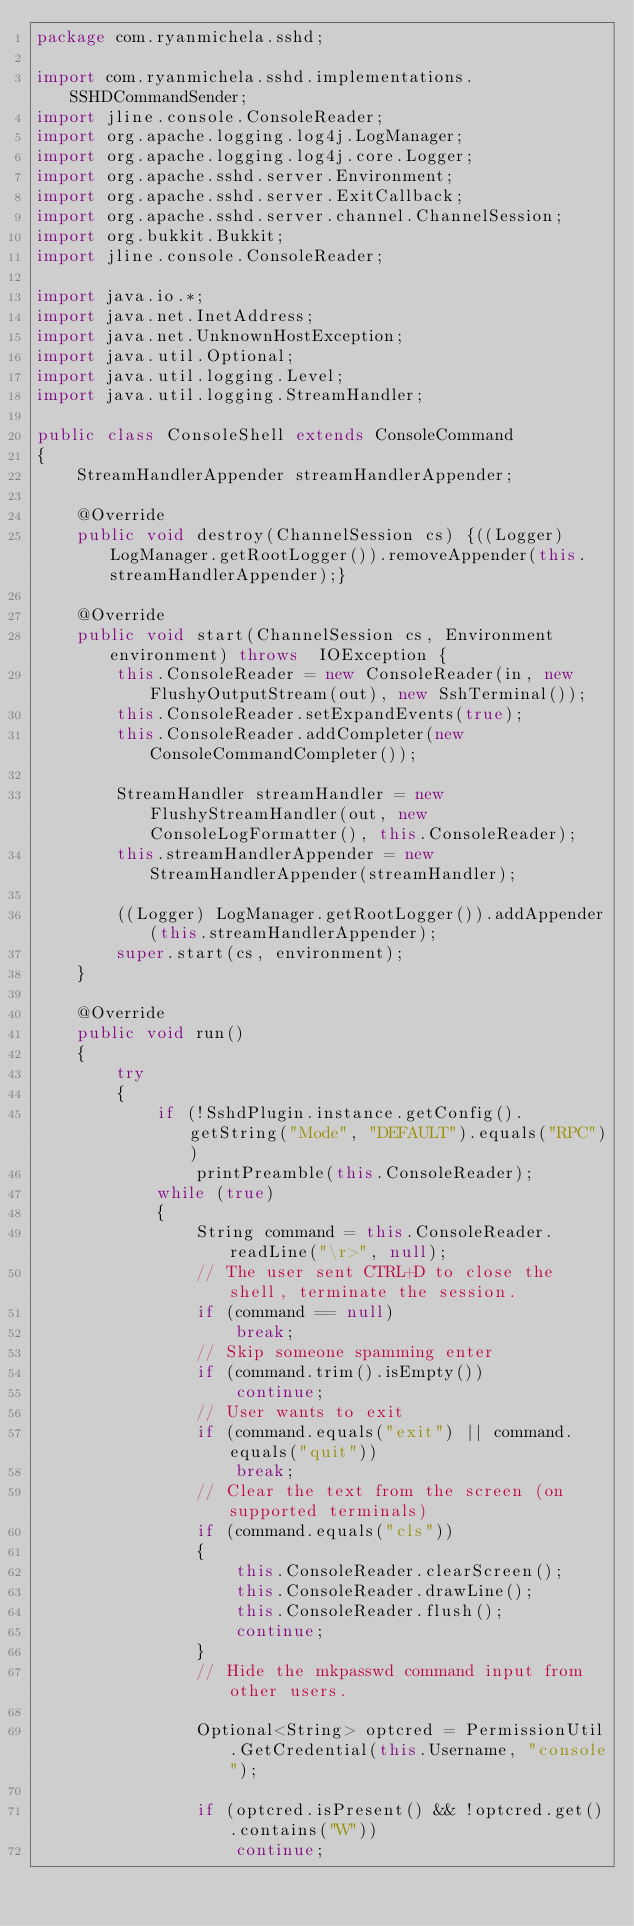<code> <loc_0><loc_0><loc_500><loc_500><_Java_>package com.ryanmichela.sshd;

import com.ryanmichela.sshd.implementations.SSHDCommandSender;
import jline.console.ConsoleReader;
import org.apache.logging.log4j.LogManager;
import org.apache.logging.log4j.core.Logger;
import org.apache.sshd.server.Environment;
import org.apache.sshd.server.ExitCallback;
import org.apache.sshd.server.channel.ChannelSession;
import org.bukkit.Bukkit;
import jline.console.ConsoleReader;

import java.io.*;
import java.net.InetAddress;
import java.net.UnknownHostException;
import java.util.Optional;
import java.util.logging.Level;
import java.util.logging.StreamHandler;

public class ConsoleShell extends ConsoleCommand
{
    StreamHandlerAppender streamHandlerAppender;

    @Override
    public void destroy(ChannelSession cs) {((Logger) LogManager.getRootLogger()).removeAppender(this.streamHandlerAppender);}

    @Override
    public void start(ChannelSession cs, Environment environment) throws  IOException {
        this.ConsoleReader = new ConsoleReader(in, new FlushyOutputStream(out), new SshTerminal());
        this.ConsoleReader.setExpandEvents(true);
        this.ConsoleReader.addCompleter(new ConsoleCommandCompleter());

        StreamHandler streamHandler = new FlushyStreamHandler(out, new ConsoleLogFormatter(), this.ConsoleReader);
        this.streamHandlerAppender = new StreamHandlerAppender(streamHandler);

        ((Logger) LogManager.getRootLogger()).addAppender(this.streamHandlerAppender);
        super.start(cs, environment);
    }

    @Override
    public void run()
    {
        try
        {
            if (!SshdPlugin.instance.getConfig().getString("Mode", "DEFAULT").equals("RPC"))
                printPreamble(this.ConsoleReader);
            while (true)
            {
                String command = this.ConsoleReader.readLine("\r>", null);
                // The user sent CTRL+D to close the shell, terminate the session.
                if (command == null)
                    break;
                // Skip someone spamming enter
                if (command.trim().isEmpty())
                    continue;
                // User wants to exit
                if (command.equals("exit") || command.equals("quit"))
                    break;
                // Clear the text from the screen (on supported terminals)
                if (command.equals("cls"))
                {
                    this.ConsoleReader.clearScreen();
                    this.ConsoleReader.drawLine();
                    this.ConsoleReader.flush();
                    continue;
                }
                // Hide the mkpasswd command input from other users.

                Optional<String> optcred = PermissionUtil.GetCredential(this.Username, "console");

                if (optcred.isPresent() && !optcred.get().contains("W"))
                    continue;</code> 